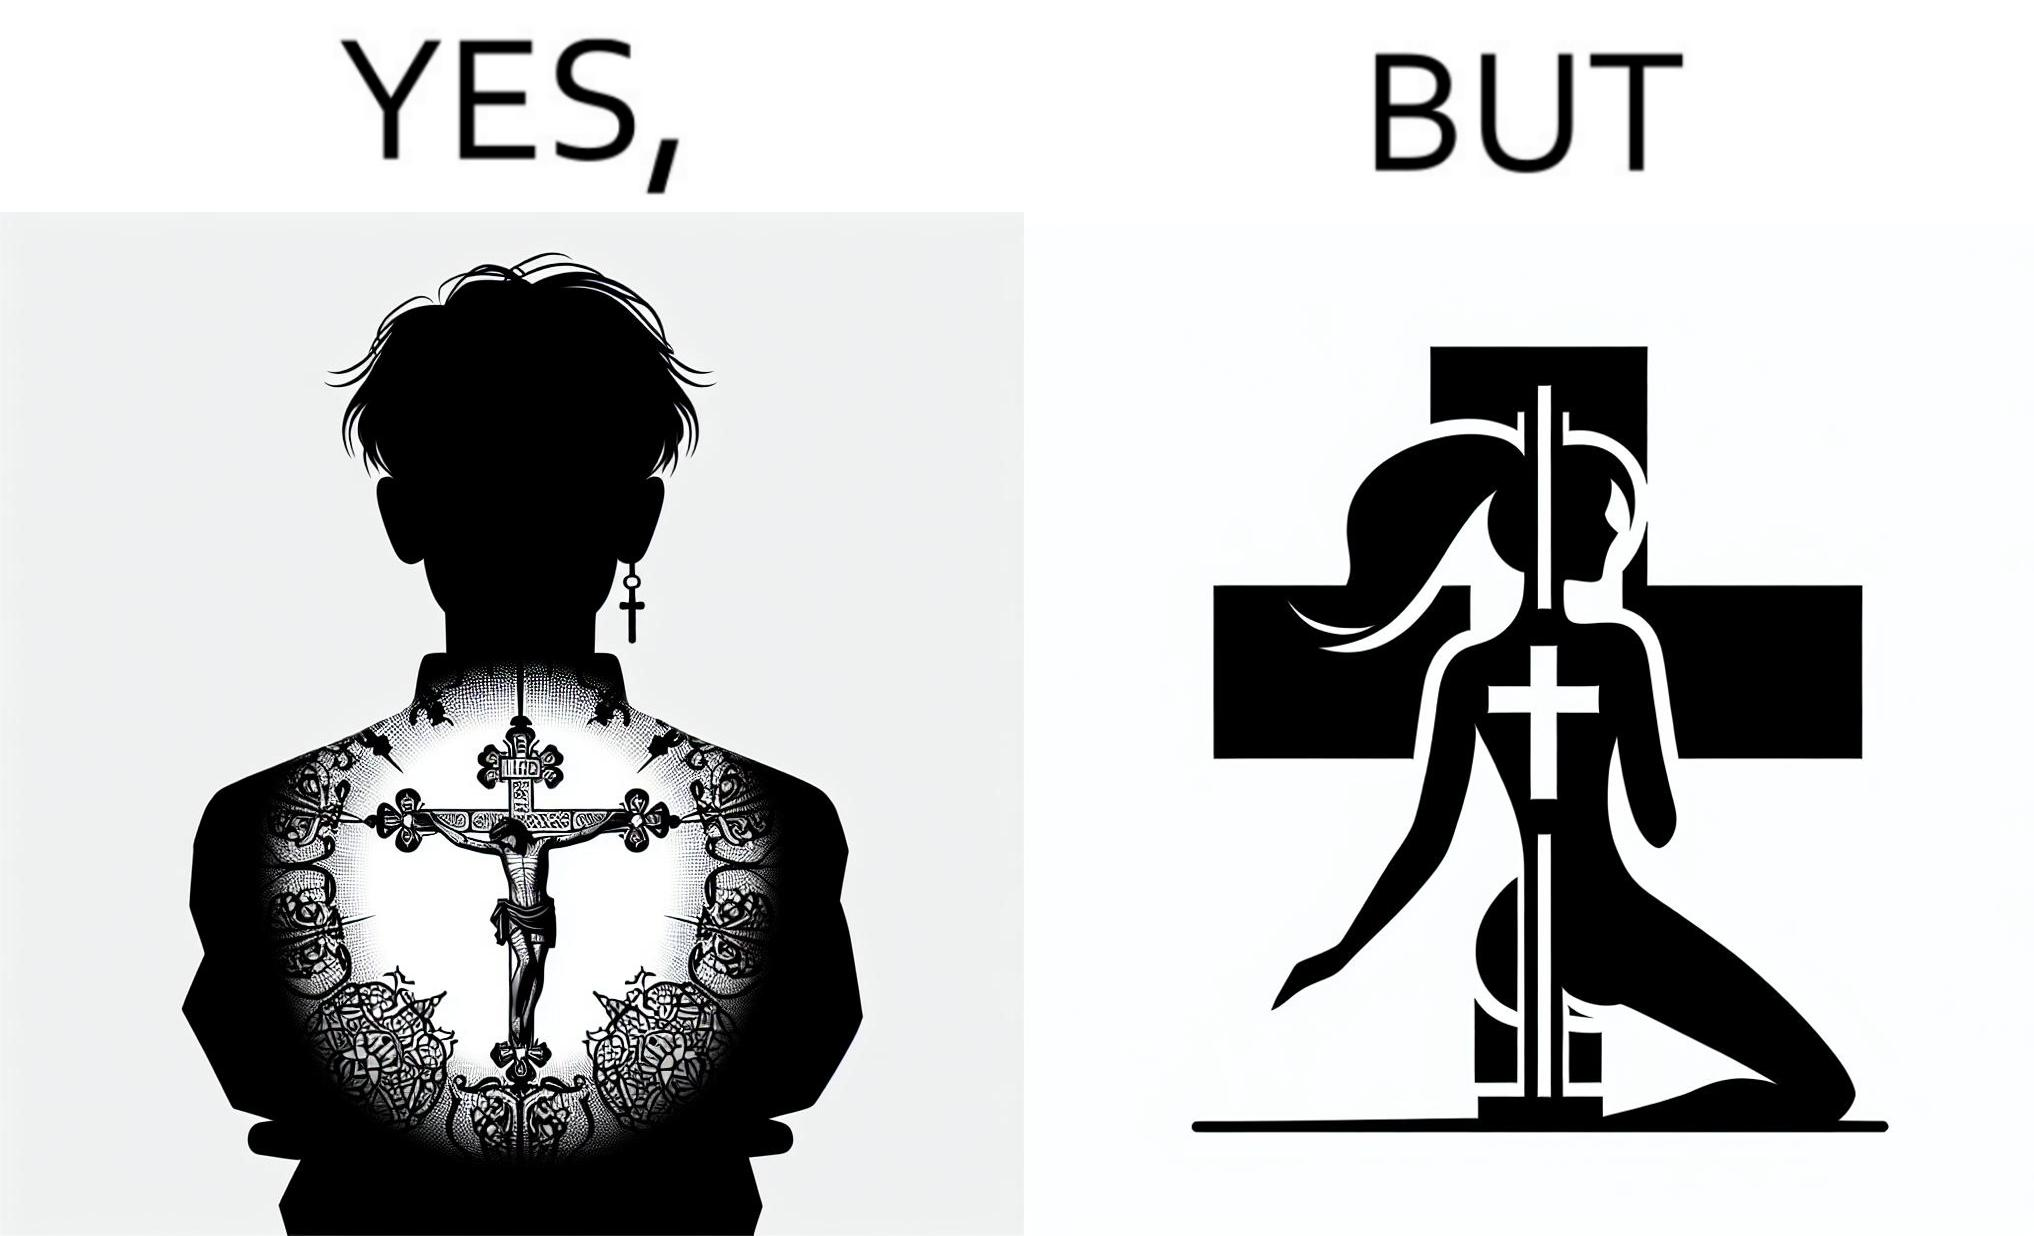What does this image depict? This image may present two different ideas, firstly even she is such a believer in god that she has got a tatto of holy cross symbol on her back but her situations have forced her to do a job at a bar or some place performing pole dance and secondly she is using a religious symbol to glorify her look so that more people acknowledge her dance and give her some money 